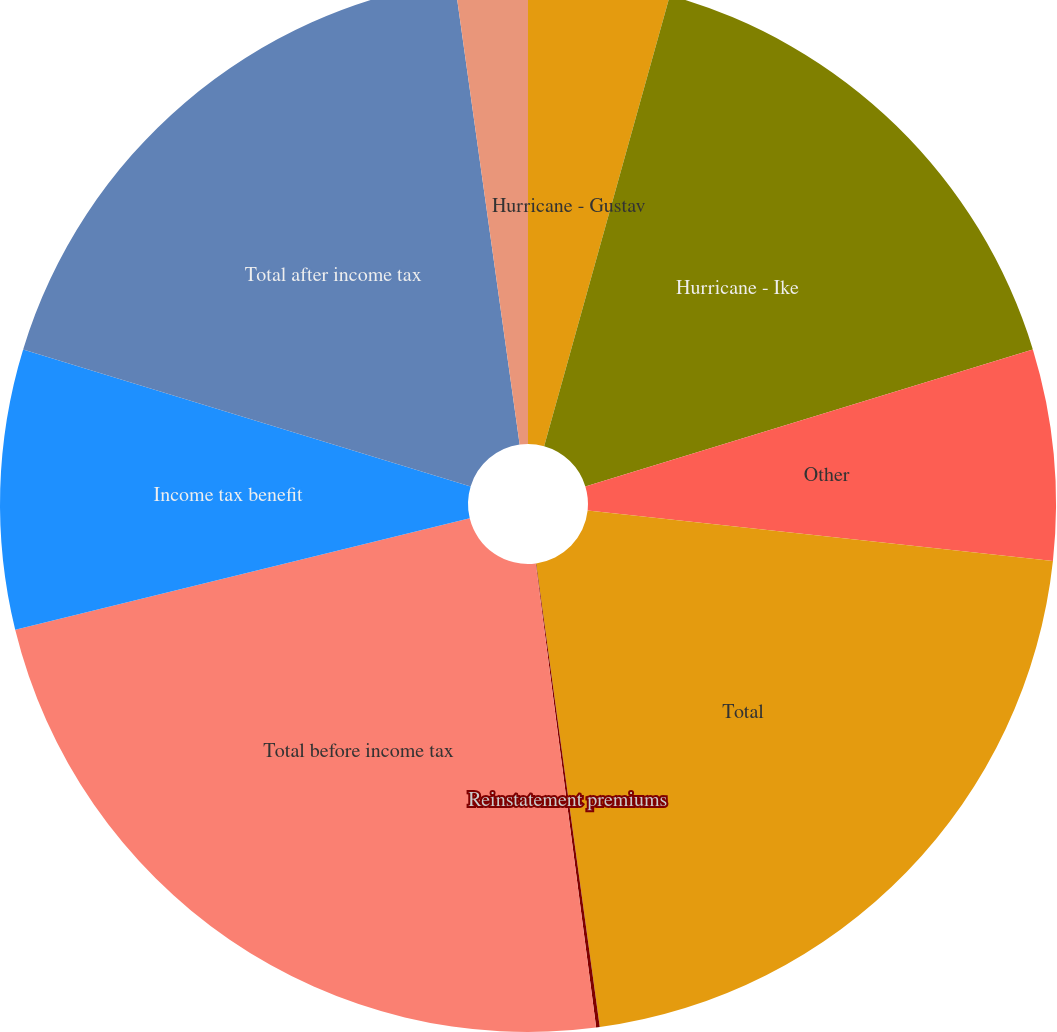<chart> <loc_0><loc_0><loc_500><loc_500><pie_chart><fcel>Hurricane - Gustav<fcel>Hurricane - Ike<fcel>Other<fcel>Total<fcel>Reinstatement premiums<fcel>Total before income tax<fcel>Income tax benefit<fcel>Total after income tax<fcel>Effective tax rate<nl><fcel>4.33%<fcel>15.94%<fcel>6.45%<fcel>21.11%<fcel>0.11%<fcel>23.23%<fcel>8.56%<fcel>18.05%<fcel>2.22%<nl></chart> 